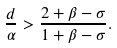Convert formula to latex. <formula><loc_0><loc_0><loc_500><loc_500>\frac { d } { \alpha } > \frac { 2 + \beta - \sigma } { 1 + \beta - \sigma } .</formula> 